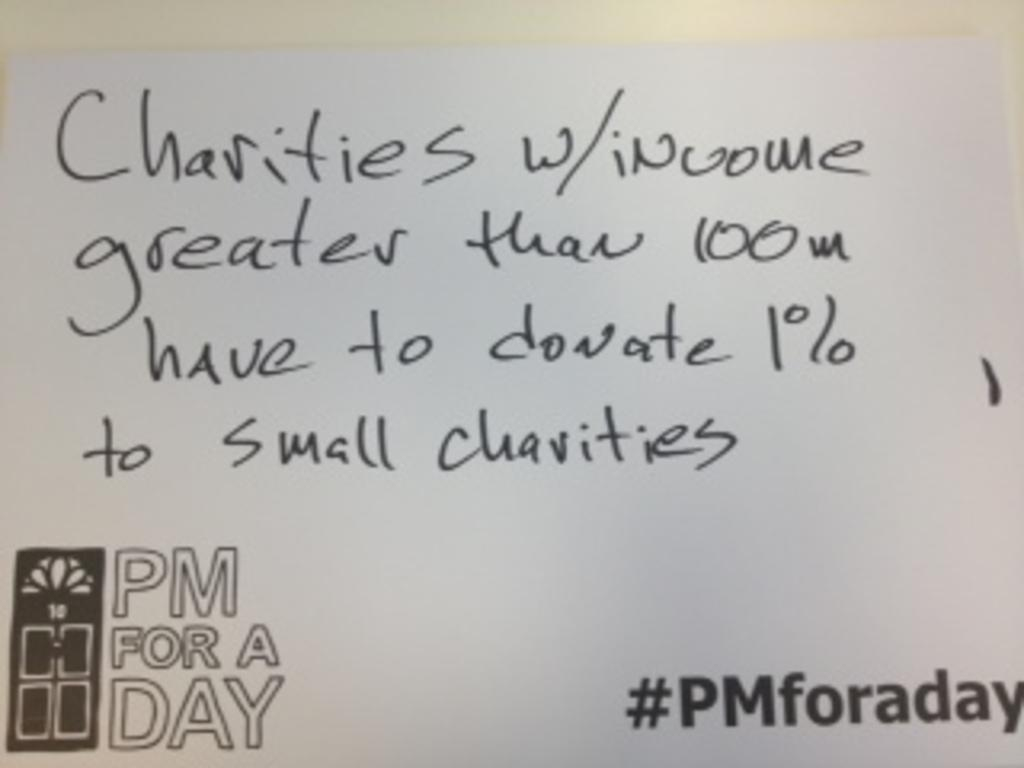<image>
Create a compact narrative representing the image presented. a paper that has charities written on it 